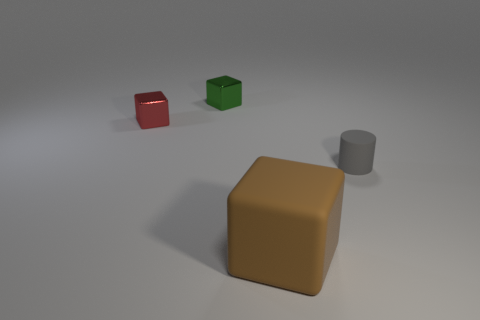There is a metallic block in front of the green shiny block; is its size the same as the cube that is in front of the cylinder?
Your response must be concise. No. There is a small thing that is on the right side of the rubber thing that is in front of the small gray thing; what is its material?
Make the answer very short. Rubber. Is the number of green metal things on the right side of the large brown rubber block less than the number of tiny matte things?
Your response must be concise. Yes. What is the shape of the tiny gray thing that is the same material as the big brown block?
Offer a terse response. Cylinder. What number of other things are there of the same shape as the tiny rubber object?
Provide a short and direct response. 0. How many cyan objects are either shiny objects or matte cylinders?
Your response must be concise. 0. Is the tiny green metallic object the same shape as the gray object?
Provide a succinct answer. No. There is a object that is right of the big block; is there a brown matte object that is on the right side of it?
Offer a terse response. No. Are there the same number of brown rubber objects behind the red metallic cube and large brown rubber cubes?
Your answer should be compact. No. What number of other things are there of the same size as the green cube?
Ensure brevity in your answer.  2. 